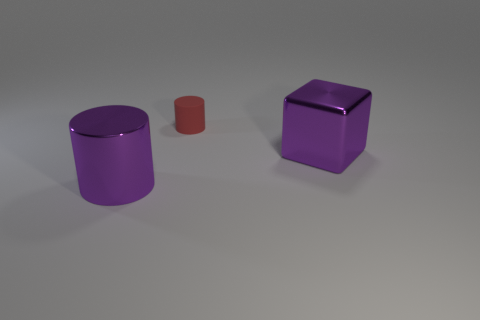Add 3 purple metallic cylinders. How many objects exist? 6 Subtract all cubes. How many objects are left? 2 Add 3 purple shiny cylinders. How many purple shiny cylinders are left? 4 Add 1 small yellow metal blocks. How many small yellow metal blocks exist? 1 Subtract 1 red cylinders. How many objects are left? 2 Subtract all metal balls. Subtract all big purple cylinders. How many objects are left? 2 